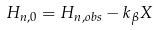<formula> <loc_0><loc_0><loc_500><loc_500>H _ { n , 0 } = H _ { n , o b s } - k _ { \beta } X</formula> 